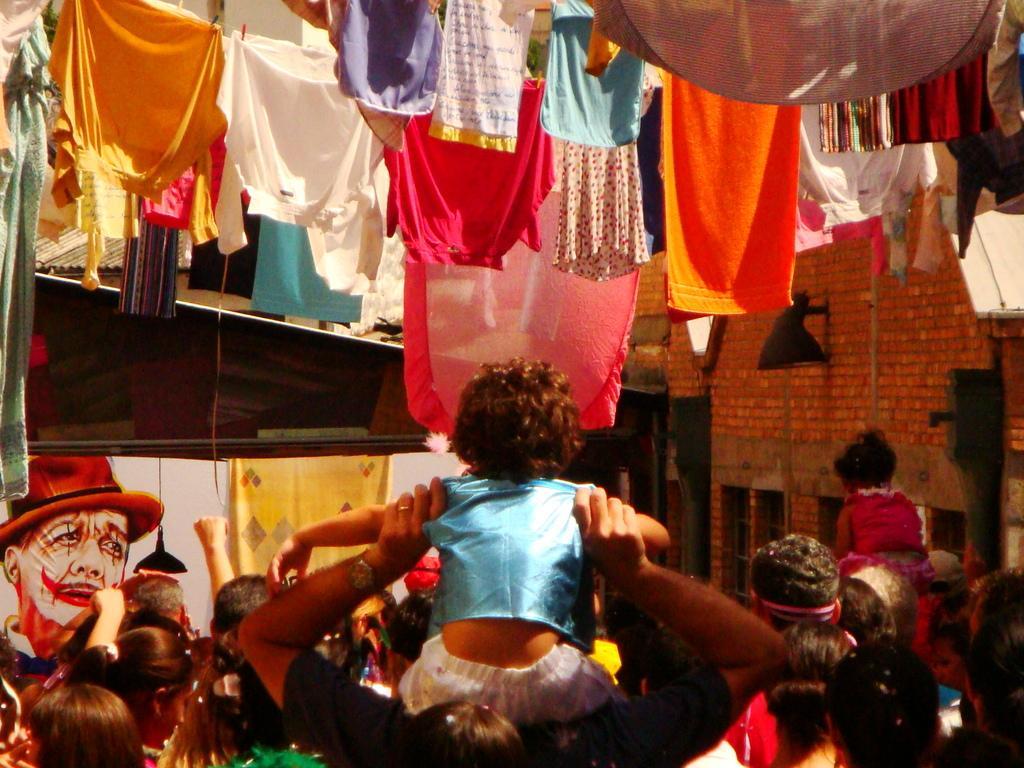Can you describe this image briefly? In this image there are a few people standing and few are holding a child on their shoulders. At the top of the image there are so many clothes hanging to the rope. In the background there is a building with red bricks. 